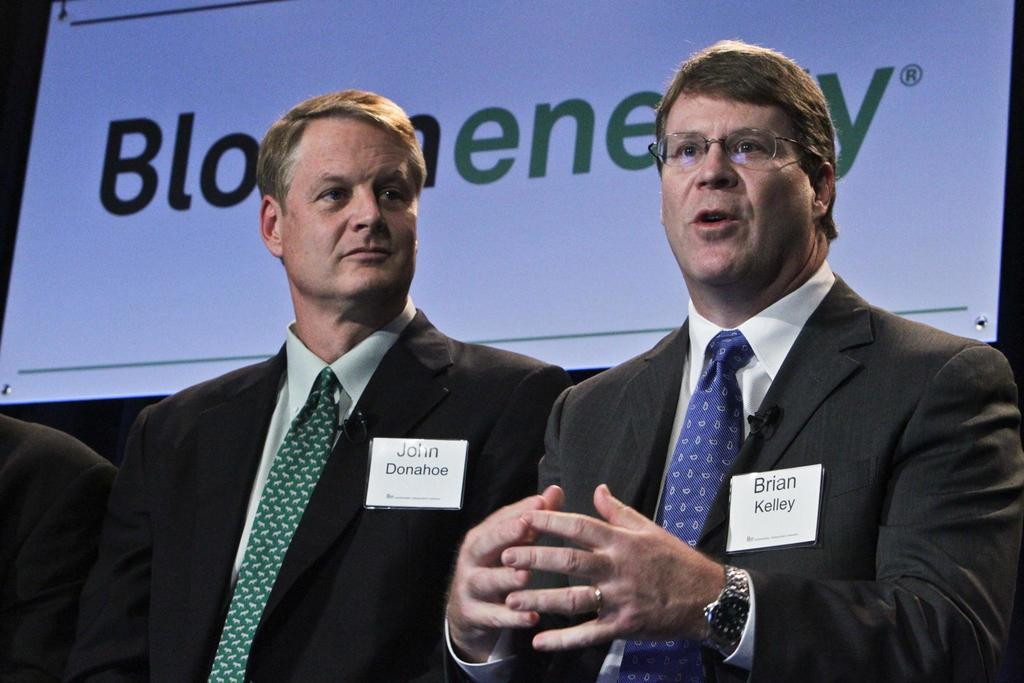How many people are in the image? There are two men in the image. What are the men doing in the image? The men are standing in the image. What are the men wearing in the image? The men are wearing coats and ties in the image. What can be seen in the background of the image? There is a white poster in the background of the image. What type of mist can be seen surrounding the men in the image? There is no mist present in the image; it is a clear scene with the men standing and wearing coats and ties. 